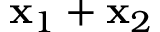Convert formula to latex. <formula><loc_0><loc_0><loc_500><loc_500>x _ { 1 } + x _ { 2 }</formula> 